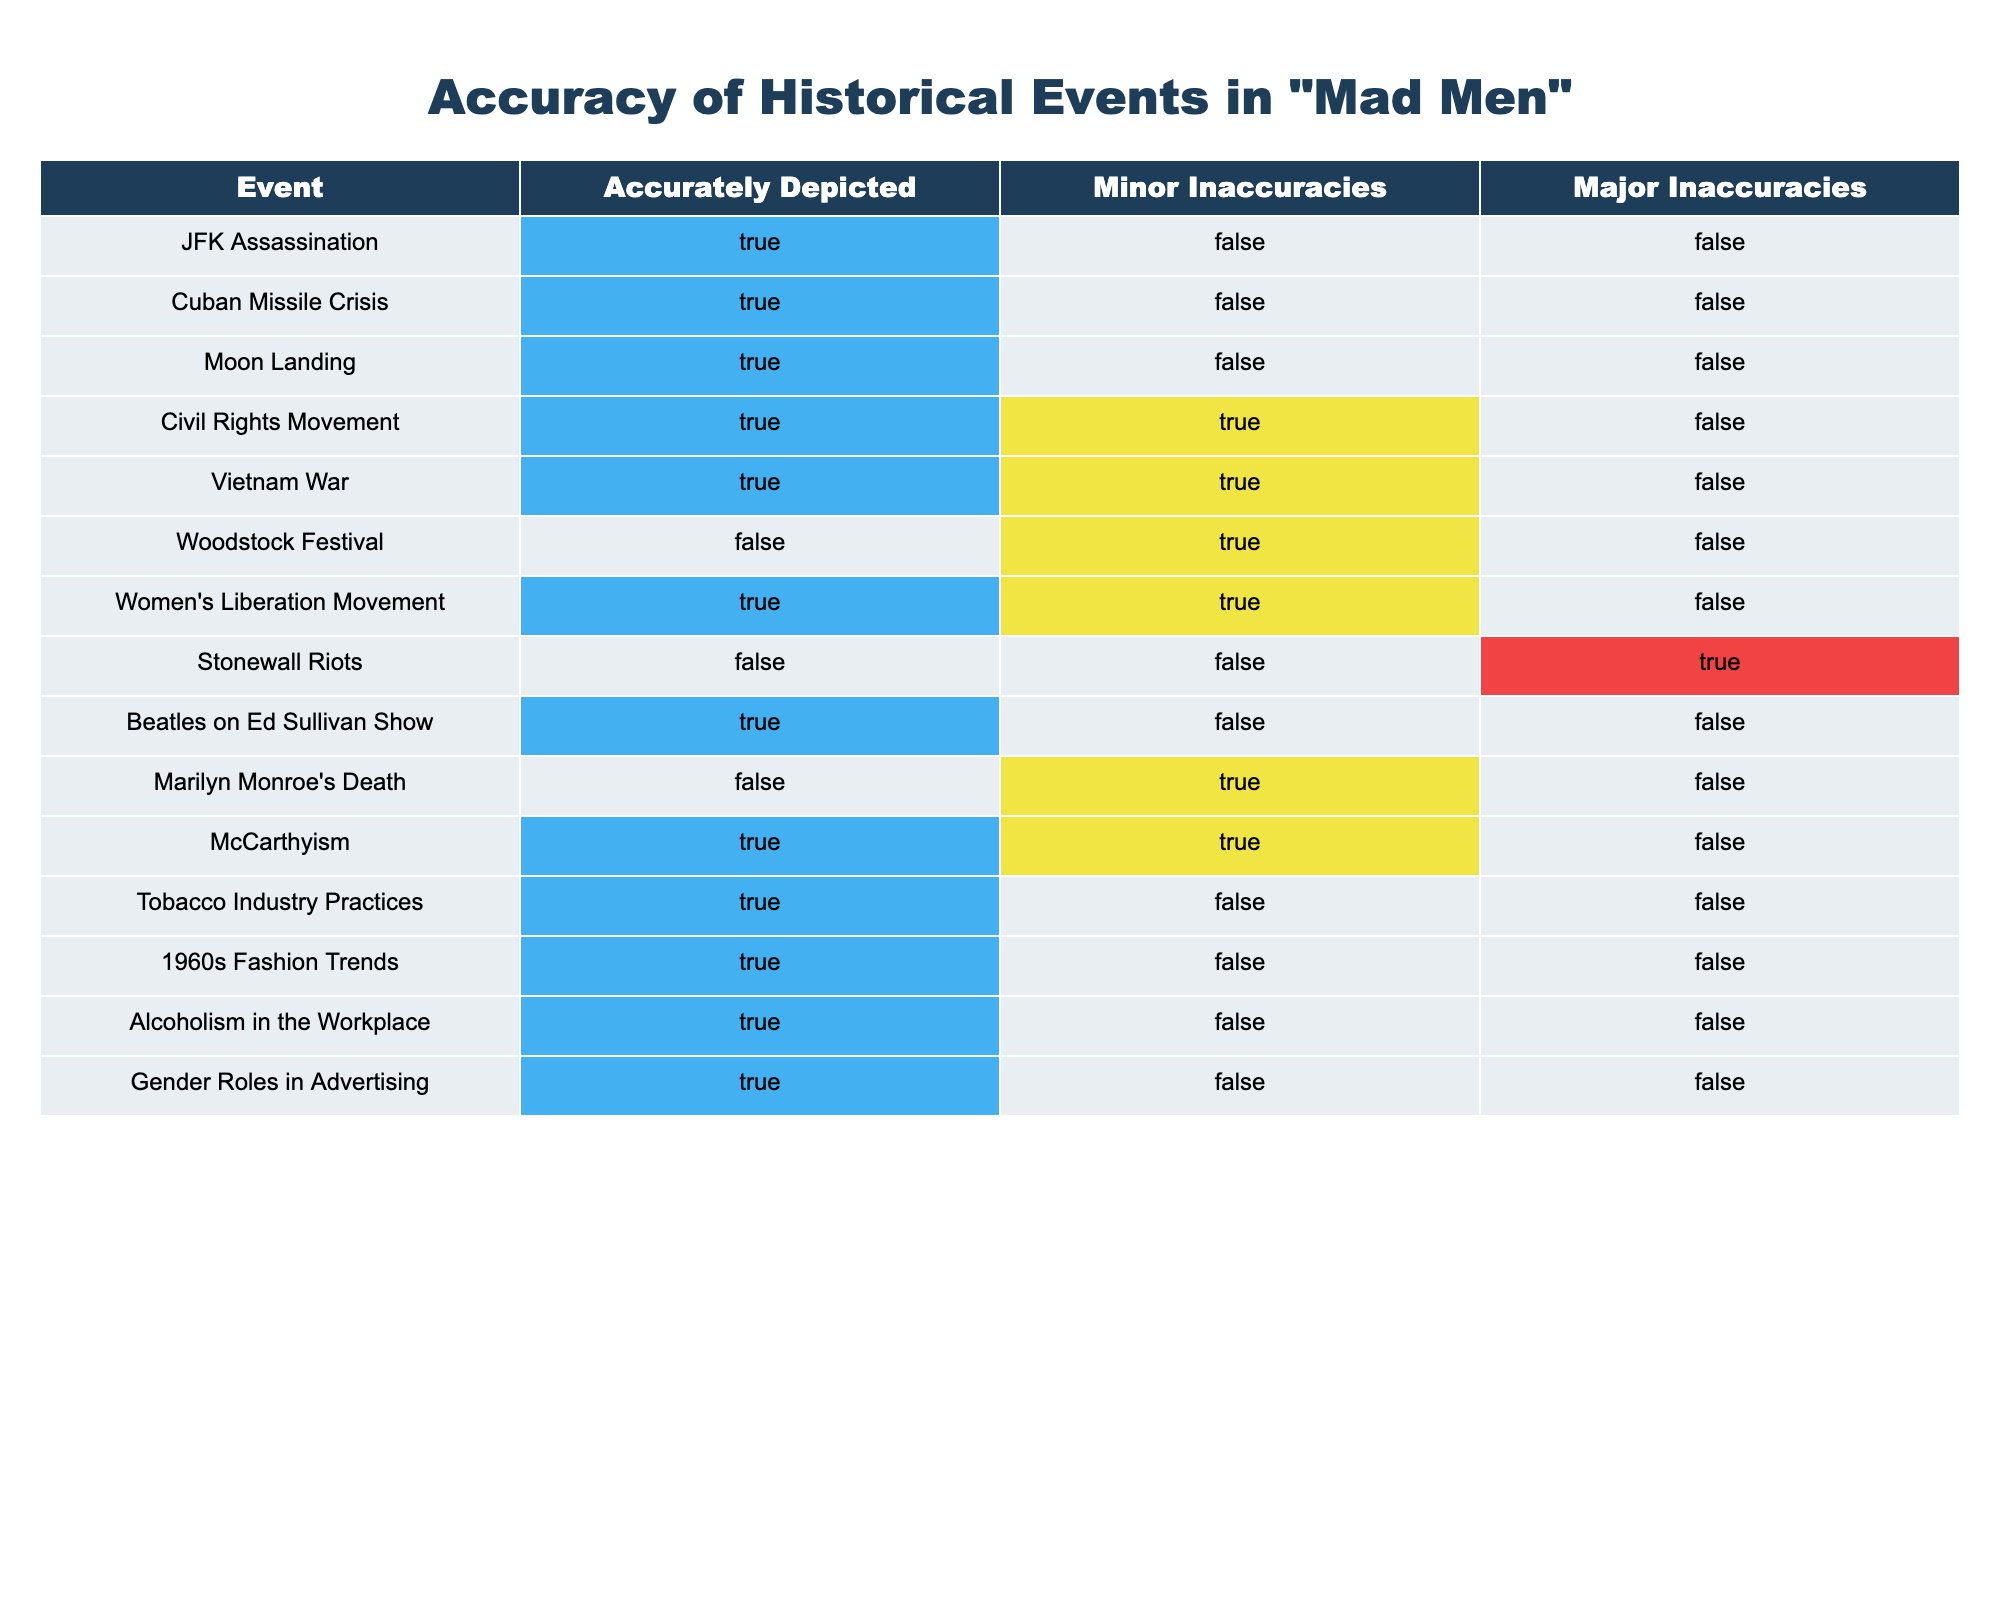What events are accurately depicted in "Mad Men"? By reviewing the "Accurately Depicted" column, we see that the events JFK Assassination, Cuban Missile Crisis, Moon Landing, Civil Rights Movement, Vietnam War, Beatles on Ed Sullivan Show, McCarthyism, Tobacco Industry Practices, 1960s Fashion Trends, Alcoholism in the Workplace, and Gender Roles in Advertising are marked as TRUE.
Answer: JFK Assassination, Cuban Missile Crisis, Moon Landing, Civil Rights Movement, Vietnam War, Beatles on Ed Sullivan Show, McCarthyism, Tobacco Industry Practices, 1960s Fashion Trends, Alcoholism in the Workplace, Gender Roles in Advertising How many historical events have minor inaccuracies in "Mad Men"? To find this, we count the number of rows where "Minor Inaccuracies" is marked as TRUE. Events such as Civil Rights Movement, Vietnam War, Woodstock Festival, Women's Liberation Movement, Marilyn Monroe's Death, and McCarthyism are included, totaling six events.
Answer: 6 Is the depiction of the Stonewall Riots considered accurate? Looking at the "Accurately Depicted" column, the Stonewall Riots are marked as FALSE, indicating that their portrayal is not accurate in the show.
Answer: No What is the total number of events with major inaccuracies? We check the "Major Inaccuracies" column for TRUE values. Only the Stonewall Riots are indicated as having a major inaccuracy, which gives us a total of one event.
Answer: 1 Among the events depicting women's movements, how many show minor inaccuracies? We check events related to women's movements, which include the Women's Liberation Movement and the Civil Rights Movement. Both these events are seen to have minor inaccuracies, so we combine these counts to find that two events showcase minor inaccuracies.
Answer: 2 Which event had both minor and major inaccuracies, and how is it categorized for accuracy? The Civil Rights Movement and Women's Liberation Movement have minor inaccuracies marked as TRUE, but both are categorized as accurately depicted in the "Accurately Depicted" column. Therefore, they have minor inaccuracies without being classified as major.
Answer: Civil Rights Movement (minor) and Women's Liberation Movement (minor) What is the only event listed that is not accurately depicted and also has no minor inaccuracies? According to the table, the Woodstock Festival is marked as inaccurately depicted with minor inaccuracies marked FALSE, making it the unique case among the events.
Answer: Woodstock Festival Which events depict the era's fashion and tobacco industry practices accurately? By looking at the "Accurately Depicted" column, we find that both the 1960s Fashion Trends and Tobacco Industry Practices are listed as accurately depicted (TRUE), indicating they are portrayed correctly in the show.
Answer: 1960s Fashion Trends and Tobacco Industry Practices 